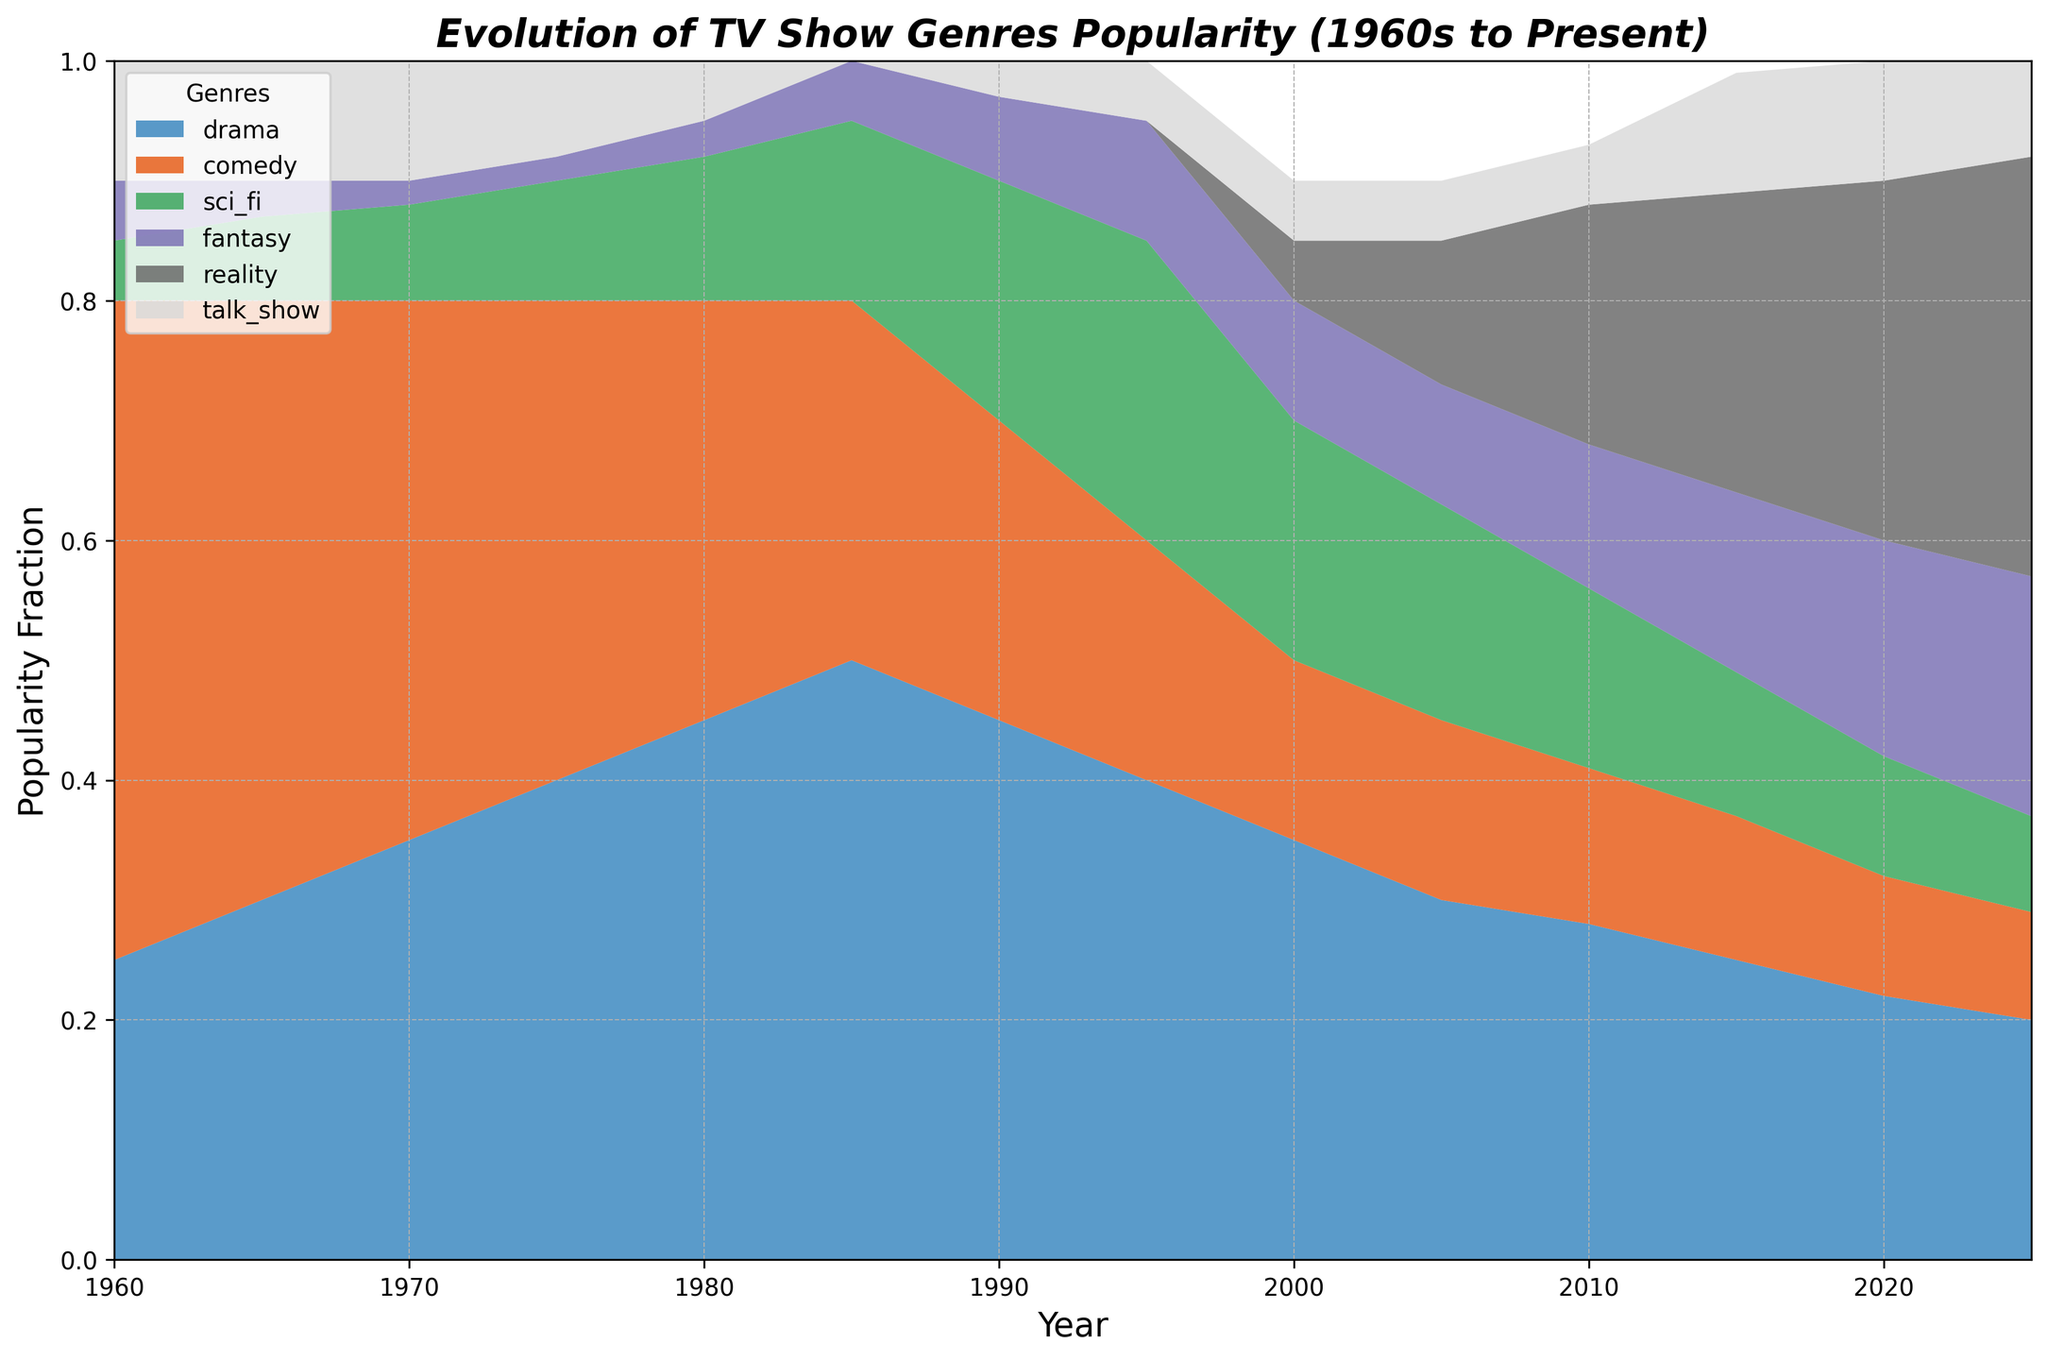What genre had the highest popularity in 1970? In the year 1970, the genre with the highest popularity fraction can be identified by looking at the area chart and comparing the height of each segment. The tallest segment corresponds to the highest popularity, which is 'drama'.
Answer: Drama Which genre showed the most significant increase in popularity from 1960 to 2025? To find out the genre with the most significant increase in popularity, compare the heights of the areas from 1960 to 2025. 'Reality' shows saw a significant rise from 0.00 in 1960 to 0.35 in 2025.
Answer: Reality During which year did the popularity of comedy and sci-fi combined equal around 0.35? Add the popularity fractions for 'comedy' and 'sci-fi' for each year and see when their sum is around 0.35. For the year 2025, the sum is 0.09 (comedy) + 0.08 (sci-fi) = 0.17. For 2020, it's 0.10 + 0.10 = 0.20. The correct year is 1980 with 0.35 (comedy) + 0.12 (sci-fi) = 0.47, closest to 0.35.
Answer: 1980 By how much did the popularity of talk shows change from 1960 to 2020? Look at the heights of the 'talk show' segments in 1960 and 2020. In 1960, it is 0.10, and in 2020, it is also 0.10, implying no change.
Answer: 0 Which year had the highest combined popularity for drama and reality genres? Sum the popularity fractions for 'drama' and 'reality' for each year and find the maximum. For 2025, the sum is 0.20 (drama) + 0.35 (reality) = 0.55, which is the highest combined value.
Answer: 2025 In what year did fantasy shows first surpass a popularity fraction of 0.15? Track the height of the 'fantasy' segment over the years. The 'fantasy' genre first exceeds 0.15 in 2015 with a fraction of 0.15.
Answer: 2015 Compare the popularity trends of drama and comedy from 1960 to 2025. Which genre showed a decline overall? Examine the overall trend lines of the 'drama' and 'comedy' segments from 1960 to 2025. 'Comedy' shows a declining trend from 0.55 in 1960 to 0.09 in 2025, while 'drama' shows an increasing trend, peaking around the 1980s and then slightly declining but still above initial levels.
Answer: Comedy 